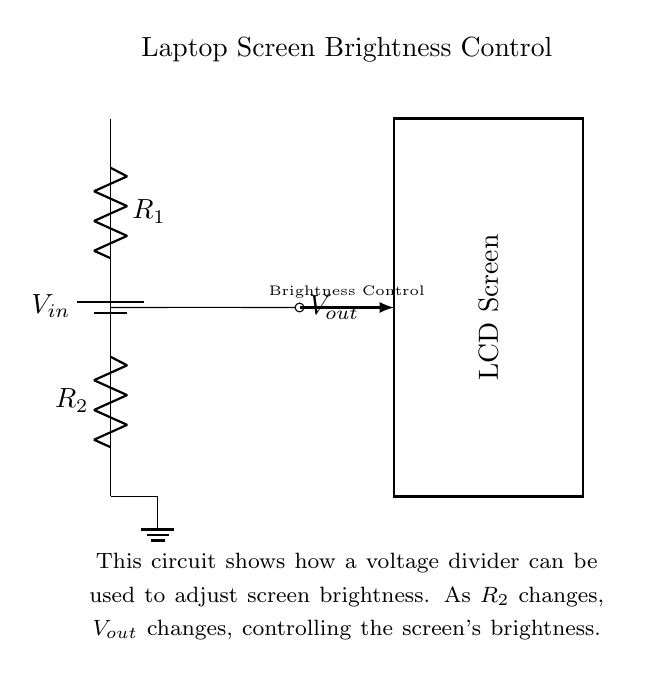What is the input voltage of this circuit? The input voltage, denoted as V_in, is indicated next to the battery symbol. It is the voltage supplied to the circuit for the brightness control.
Answer: V_in What are the names of the two resistors in the circuit? The two resistors are labeled as R_1 and R_2. These labels are found on the circuit diagram next to their respective symbols.
Answer: R_1 and R_2 How does changing R_2 affect the output voltage? Changing R_2 alters the resistance in the voltage divider circuit, which directly affects the output voltage V_out according to the voltage division rule. When R_2 increases, V_out decreases, thus dimming the screen.
Answer: V_out changes What does V_out represent in the circuit? V_out represents the output voltage from the voltage divider, which is used to control the brightness of the LCD screen. It is the voltage measured at the junction of R_1 and R_2.
Answer: Brightness control voltage What is the purpose of the voltage divider in this circuit? The purpose of the voltage divider is to reduce the input voltage to a lower level suitable for controlling the brightness of the LCD screen. It allows adjustment of V_out for brightness settings.
Answer: Screen brightness adjustment How does the circuit ensure brightness control? The circuit uses a voltage divider configuration, where varying the resistance of R_2 modifies the output voltage, allowing for precise control over the brightness of the screen as indicated by the output voltage V_out.
Answer: Via voltage division 